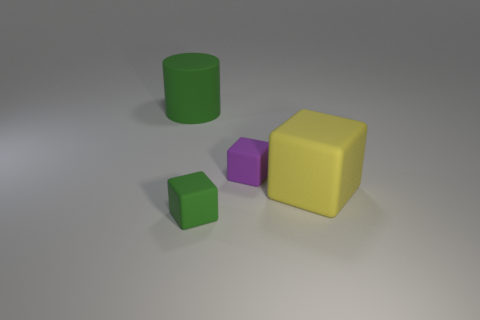Is the large block made of the same material as the green block?
Give a very brief answer. Yes. What is the color of the small matte object that is to the left of the tiny rubber block that is right of the small green thing?
Give a very brief answer. Green. What size is the yellow object that is the same shape as the purple matte thing?
Keep it short and to the point. Large. There is a large green matte cylinder behind the small thing that is behind the big yellow matte block; what number of tiny green rubber objects are left of it?
Provide a short and direct response. 0. Are there more green cubes than tiny yellow metallic cylinders?
Your answer should be compact. Yes. What number of green things are there?
Provide a short and direct response. 2. What is the shape of the small rubber thing behind the green rubber object to the right of the big object left of the small purple block?
Make the answer very short. Cube. Are there fewer big yellow rubber objects behind the large yellow cube than things that are behind the tiny purple matte block?
Offer a terse response. Yes. Does the large matte object on the right side of the small green cube have the same shape as the large matte thing that is behind the big yellow matte cube?
Make the answer very short. No. What is the shape of the big matte thing that is on the left side of the small block that is in front of the yellow matte thing?
Your response must be concise. Cylinder. 